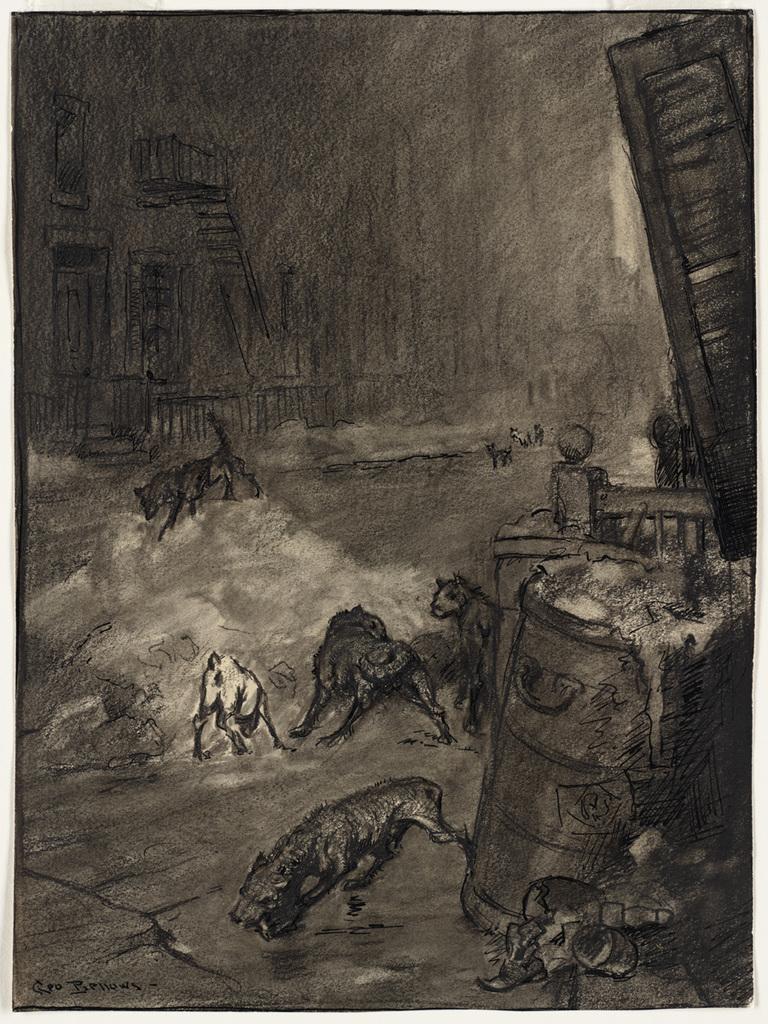Describe this image in one or two sentences. In this image we can see a sketch of the animals, grills, wall, person and some other objects. 